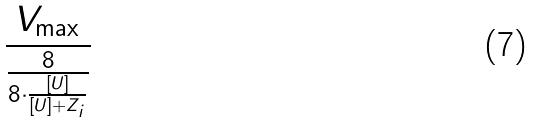<formula> <loc_0><loc_0><loc_500><loc_500>\frac { V _ { \max } } { \frac { 8 } { 8 \cdot \frac { [ U ] } { [ U ] + Z _ { i } } } }</formula> 